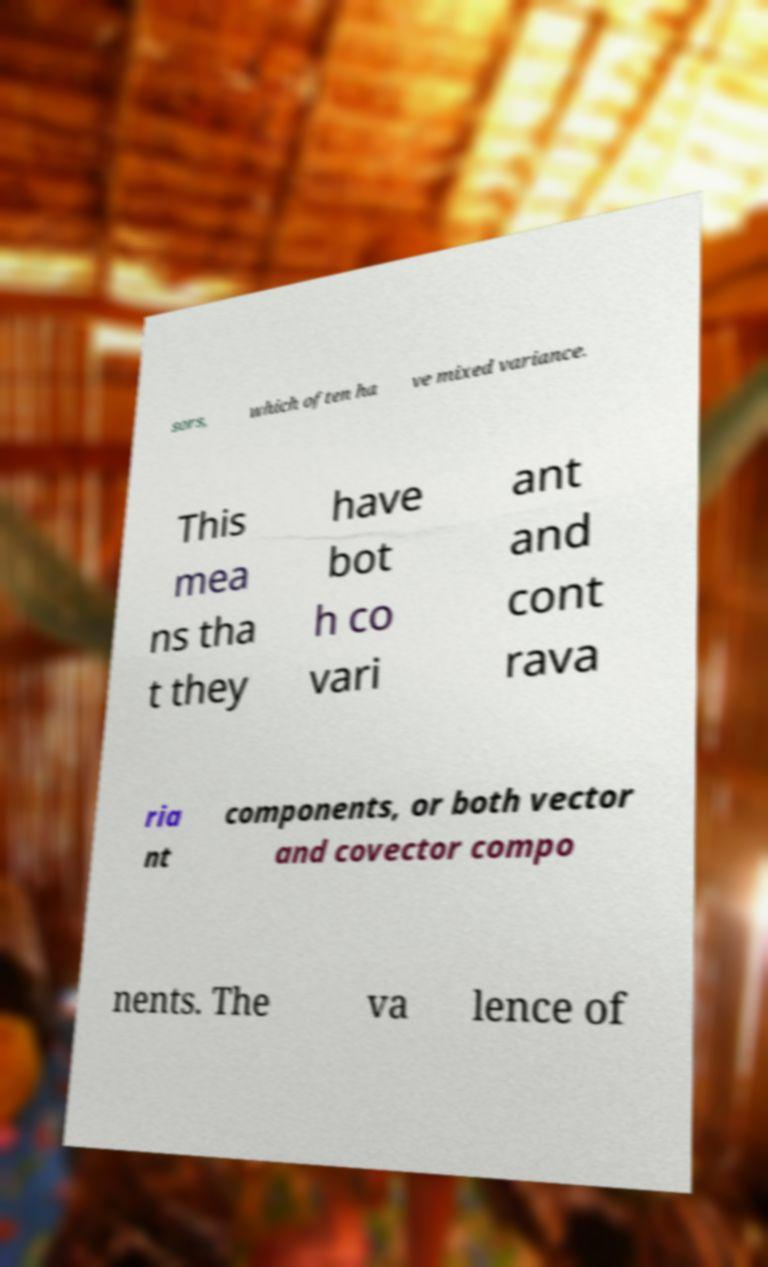For documentation purposes, I need the text within this image transcribed. Could you provide that? sors, which often ha ve mixed variance. This mea ns tha t they have bot h co vari ant and cont rava ria nt components, or both vector and covector compo nents. The va lence of 